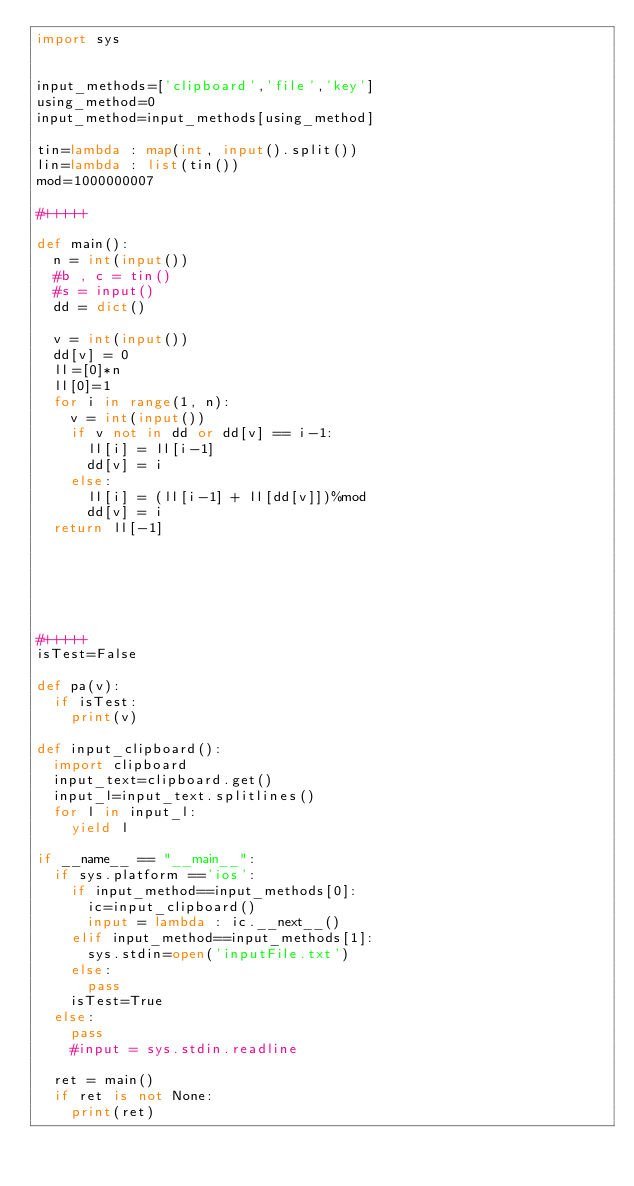<code> <loc_0><loc_0><loc_500><loc_500><_Python_>import sys


input_methods=['clipboard','file','key']
using_method=0
input_method=input_methods[using_method]

tin=lambda : map(int, input().split())
lin=lambda : list(tin())
mod=1000000007

#+++++

def main():
	n = int(input())
	#b , c = tin()
	#s = input()
	dd = dict()
	
	v = int(input())
	dd[v] = 0
	ll=[0]*n
	ll[0]=1
	for i in range(1, n):
		v = int(input())
		if v not in dd or dd[v] == i-1:
			ll[i] = ll[i-1]
			dd[v] = i
		else:
			ll[i] = (ll[i-1] + ll[dd[v]])%mod
			dd[v] = i
	return ll[-1]
			
		
	
	
	
	
#+++++
isTest=False

def pa(v):
	if isTest:
		print(v)
		
def input_clipboard():
	import clipboard
	input_text=clipboard.get()
	input_l=input_text.splitlines()
	for l in input_l:
		yield l

if __name__ == "__main__":
	if sys.platform =='ios':
		if input_method==input_methods[0]:
			ic=input_clipboard()
			input = lambda : ic.__next__()
		elif input_method==input_methods[1]:
			sys.stdin=open('inputFile.txt')
		else:
			pass
		isTest=True
	else:
		pass
		#input = sys.stdin.readline
			
	ret = main()
	if ret is not None:
		print(ret)</code> 